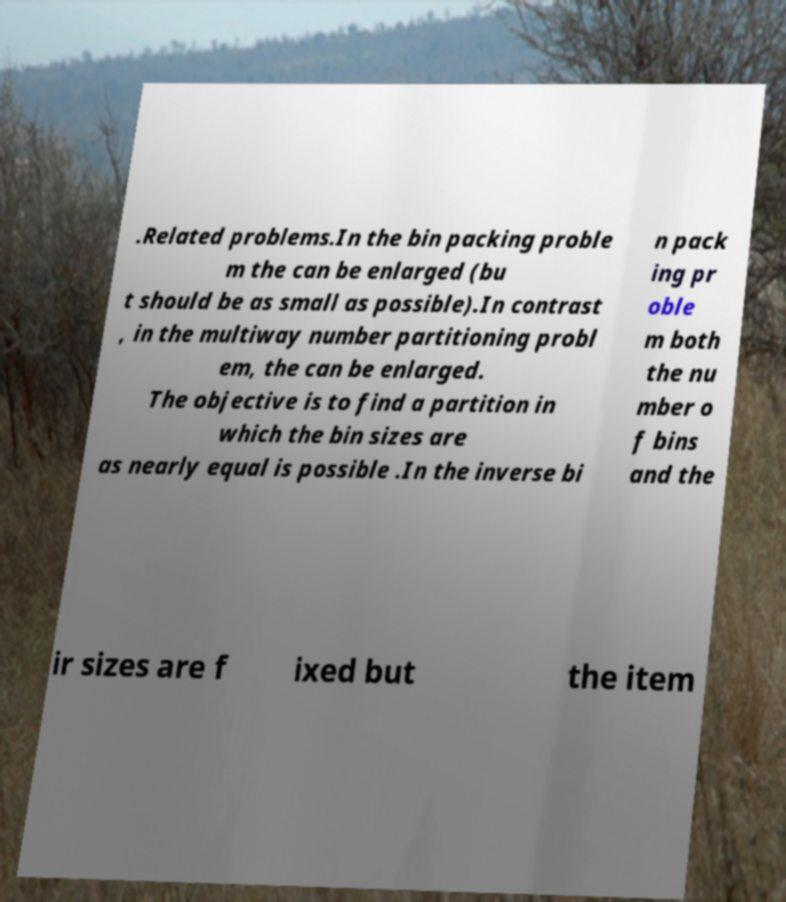I need the written content from this picture converted into text. Can you do that? .Related problems.In the bin packing proble m the can be enlarged (bu t should be as small as possible).In contrast , in the multiway number partitioning probl em, the can be enlarged. The objective is to find a partition in which the bin sizes are as nearly equal is possible .In the inverse bi n pack ing pr oble m both the nu mber o f bins and the ir sizes are f ixed but the item 